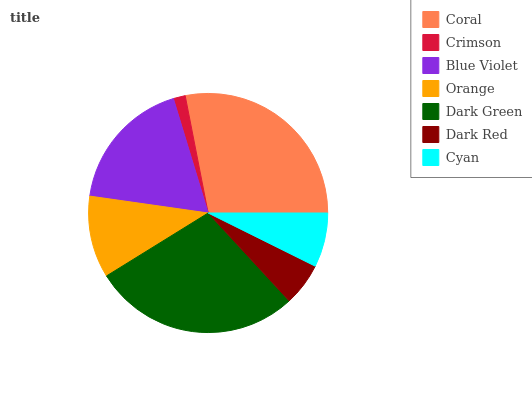Is Crimson the minimum?
Answer yes or no. Yes. Is Coral the maximum?
Answer yes or no. Yes. Is Blue Violet the minimum?
Answer yes or no. No. Is Blue Violet the maximum?
Answer yes or no. No. Is Blue Violet greater than Crimson?
Answer yes or no. Yes. Is Crimson less than Blue Violet?
Answer yes or no. Yes. Is Crimson greater than Blue Violet?
Answer yes or no. No. Is Blue Violet less than Crimson?
Answer yes or no. No. Is Orange the high median?
Answer yes or no. Yes. Is Orange the low median?
Answer yes or no. Yes. Is Coral the high median?
Answer yes or no. No. Is Coral the low median?
Answer yes or no. No. 